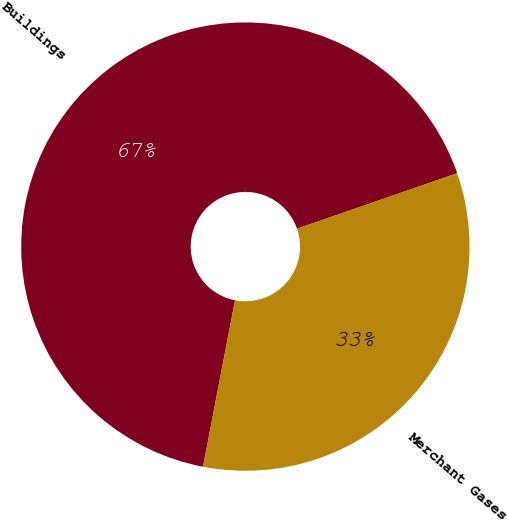Convert chart to OTSL. <chart><loc_0><loc_0><loc_500><loc_500><pie_chart><fcel>Buildings<fcel>Merchant Gases<nl><fcel>66.67%<fcel>33.33%<nl></chart> 